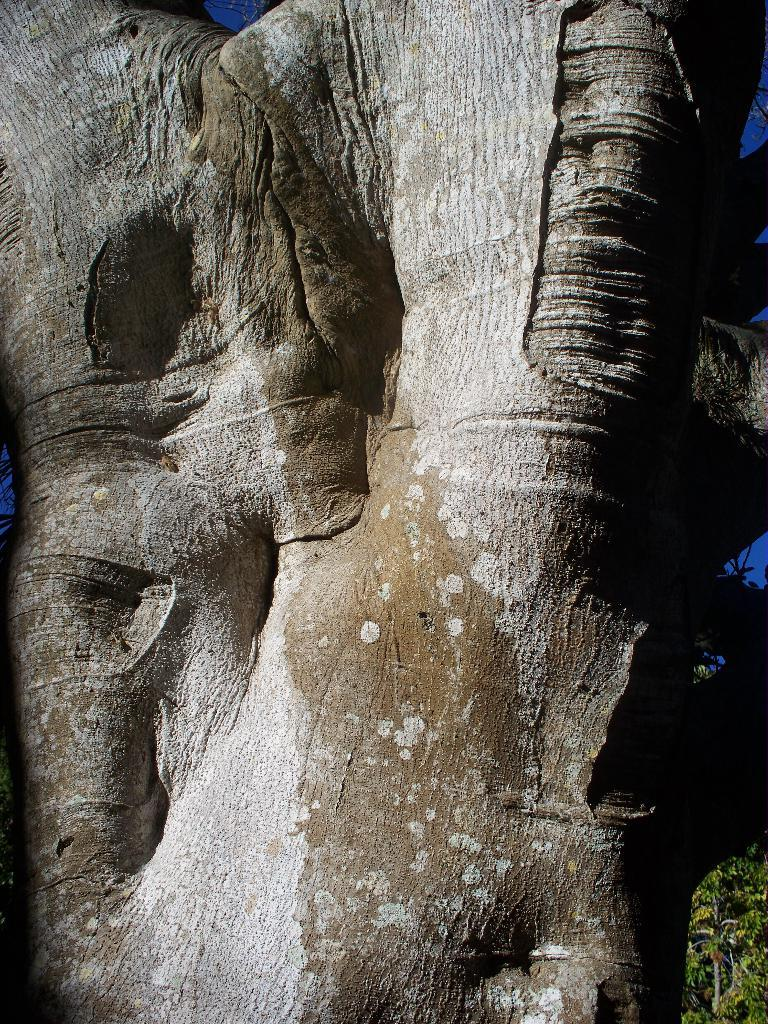What is the main subject of the image? The main subject of the image is a branch of a tree. Can you describe the branch in more detail? Unfortunately, the provided facts do not give any additional details about the branch. What type of condition is the nail in, and how does it affect the branch in the image? There is no mention of a nail in the provided facts, so we cannot answer this question. 